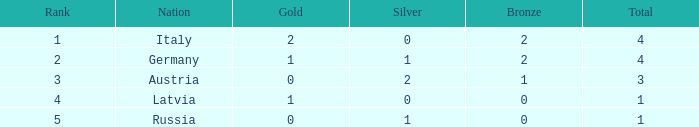What is the mean quantity of silver medals for nations with 0 gold and position below 3? None. 